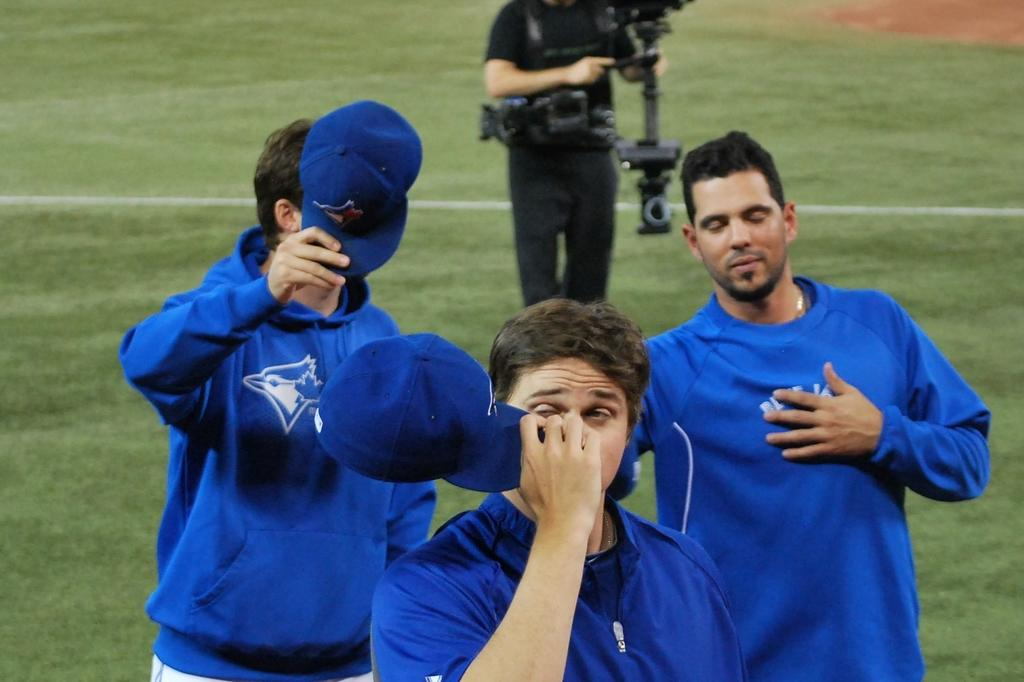What type of vegetation can be seen in the image? There is green grass in the image. What is the man wearing in the image? The man is wearing black attire in the image. What is the man holding in the image? The man is holding a camera in the image. What color are the t-shirts worn by some people in the image? There are people wearing blue t-shirts in the image. What type of headwear is visible in the image? There are blue caps visible in the image. What suggestion does the man's mom give him for his birthday in the image? There is no mention of a mom, birthday, or suggestion in the image. The man is simply holding a camera and wearing black attire. 